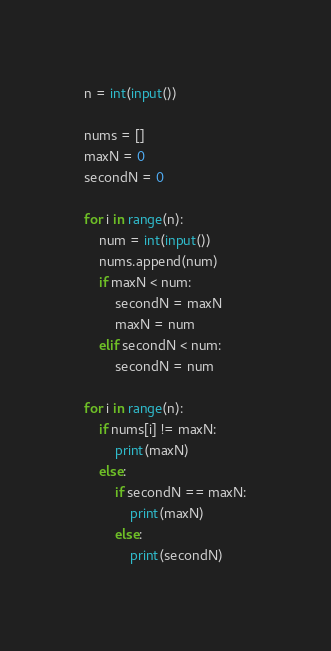Convert code to text. <code><loc_0><loc_0><loc_500><loc_500><_Python_>n = int(input())

nums = []
maxN = 0
secondN = 0

for i in range(n):
    num = int(input())
    nums.append(num)
    if maxN < num:
        secondN = maxN
        maxN = num
    elif secondN < num:
        secondN = num

for i in range(n):
    if nums[i] != maxN:
        print(maxN)
    else:
        if secondN == maxN:
            print(maxN)
        else:
            print(secondN)</code> 